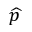<formula> <loc_0><loc_0><loc_500><loc_500>\widehat { p }</formula> 